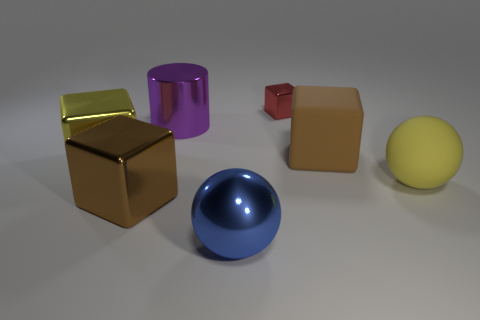What shape is the blue object that is the same size as the metallic cylinder?
Ensure brevity in your answer.  Sphere. How many other things are there of the same shape as the yellow metal object?
Provide a short and direct response. 3. Does the shiny sphere have the same size as the brown cube right of the small red cube?
Provide a short and direct response. Yes. How many things are yellow objects that are on the left side of the large brown shiny object or large green cylinders?
Make the answer very short. 1. There is a big yellow object to the left of the small red metal object; what shape is it?
Offer a very short reply. Cube. Are there an equal number of red metallic things in front of the blue shiny thing and yellow matte objects left of the brown metallic object?
Your response must be concise. Yes. There is a thing that is both in front of the large yellow matte sphere and to the right of the big purple shiny cylinder; what color is it?
Your answer should be very brief. Blue. What is the material of the brown block behind the large yellow thing that is left of the red shiny cube?
Your response must be concise. Rubber. Do the matte cube and the red metal object have the same size?
Give a very brief answer. No. What number of small things are red cylinders or yellow balls?
Your answer should be very brief. 0. 